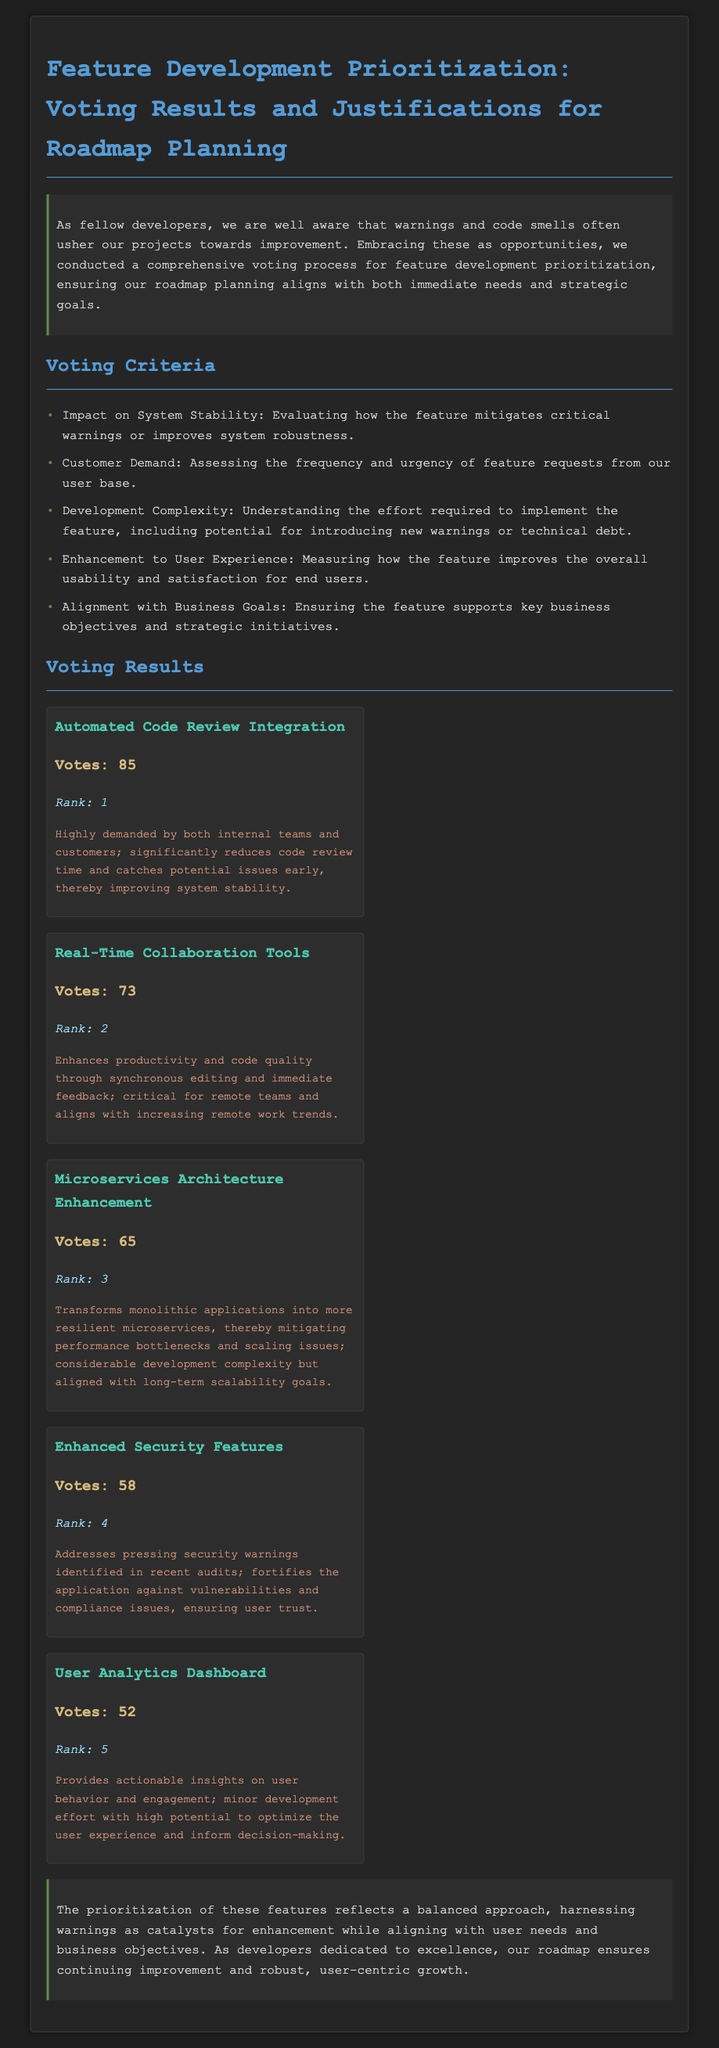what is the title of the document? The title is specified in the header tag and describes the content of the document regarding feature development prioritization.
Answer: Feature Development Prioritization: Voting Results and Justifications for Roadmap Planning how many votes did the Automated Code Review Integration receive? The votes for this feature can be found in the voting results section, alongside its name.
Answer: 85 which feature ranked second? The ranking of features is indicated in the vote results section with their respective titles and ranks.
Answer: Real-Time Collaboration Tools what is the justification for Enhanced Security Features? The justification is provided in the voting results section, reflecting the feature's significance and impact.
Answer: Addresses pressing security warnings identified in recent audits; fortifies the application against vulnerabilities and compliance issues, ensuring user trust how many features are listed in the voting results? The count of features can be determined by counting the individual sections presented under the voting results header.
Answer: 5 which criteria focuses on user interactions? The criteria outlined in the document pertain to different aspects of feature development, with one targeting user satisfaction.
Answer: Enhancement to User Experience what feature has the lowest vote count? The feature with the least number of votes is noted in the voting results section, showing its relative placement in comparison to others.
Answer: User Analytics Dashboard what is the color used for the feature names? The color mentioned in the document is applied to the feature names to distinguish them visually from other text elements.
Answer: #4ec9b0 which feature has a significant impact on system stability? The document justifies features based on various impacts, including stability, and highlights one that significantly addresses this concern.
Answer: Automated Code Review Integration 